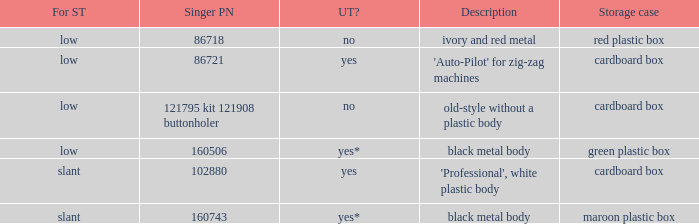What's the description of the buttonholer whose singer part number is 121795 kit 121908 buttonholer? Old-style without a plastic body. 